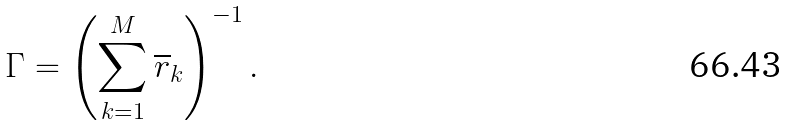<formula> <loc_0><loc_0><loc_500><loc_500>\Gamma = \left ( \sum _ { k = 1 } ^ { M } \overline { r } _ { k } \right ) ^ { - 1 } .</formula> 